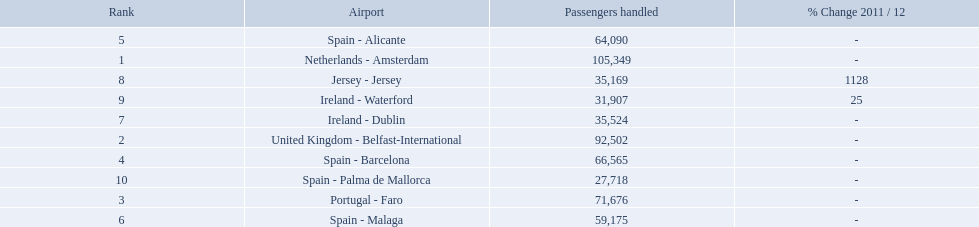Name all the london southend airports that did not list a change in 2001/12. Netherlands - Amsterdam, United Kingdom - Belfast-International, Portugal - Faro, Spain - Barcelona, Spain - Alicante, Spain - Malaga, Ireland - Dublin, Spain - Palma de Mallorca. What unchanged percentage airports from 2011/12 handled less then 50,000 passengers? Ireland - Dublin, Spain - Palma de Mallorca. Parse the table in full. {'header': ['Rank', 'Airport', 'Passengers handled', '% Change 2011 / 12'], 'rows': [['5', 'Spain - Alicante', '64,090', '-'], ['1', 'Netherlands - Amsterdam', '105,349', '-'], ['8', 'Jersey - Jersey', '35,169', '1128'], ['9', 'Ireland - Waterford', '31,907', '25'], ['7', 'Ireland - Dublin', '35,524', '-'], ['2', 'United Kingdom - Belfast-International', '92,502', '-'], ['4', 'Spain - Barcelona', '66,565', '-'], ['10', 'Spain - Palma de Mallorca', '27,718', '-'], ['3', 'Portugal - Faro', '71,676', '-'], ['6', 'Spain - Malaga', '59,175', '-']]} What unchanged percentage airport from 2011/12 handled less then 50,000 passengers is the closest to the equator? Spain - Palma de Mallorca. What are all the airports in the top 10 busiest routes to and from london southend airport? Netherlands - Amsterdam, United Kingdom - Belfast-International, Portugal - Faro, Spain - Barcelona, Spain - Alicante, Spain - Malaga, Ireland - Dublin, Jersey - Jersey, Ireland - Waterford, Spain - Palma de Mallorca. Which airports are in portugal? Portugal - Faro. 